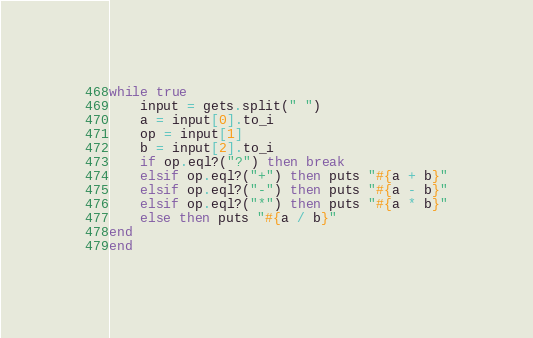<code> <loc_0><loc_0><loc_500><loc_500><_Ruby_>while true
	input = gets.split(" ")
	a = input[0].to_i
	op = input[1]
	b = input[2].to_i
	if op.eql?("?") then break
	elsif op.eql?("+") then puts "#{a + b}"
	elsif op.eql?("-") then puts "#{a - b}"
	elsif op.eql?("*") then puts "#{a * b}"
	else then puts "#{a / b}"
end
end</code> 